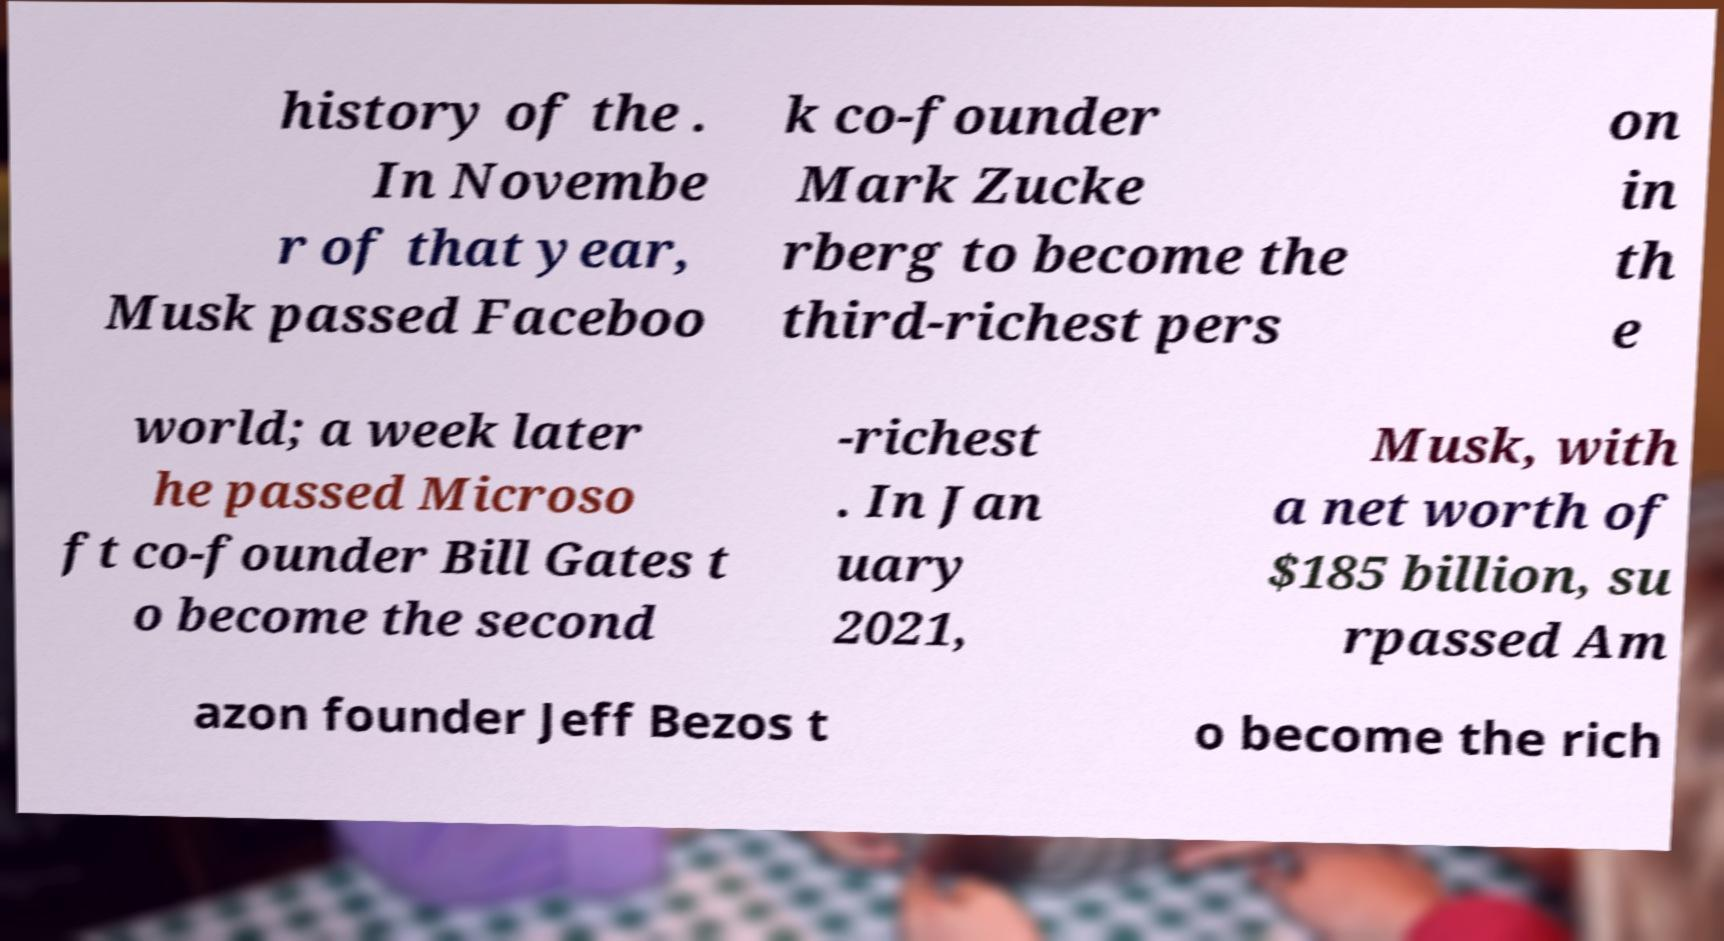What messages or text are displayed in this image? I need them in a readable, typed format. history of the . In Novembe r of that year, Musk passed Faceboo k co-founder Mark Zucke rberg to become the third-richest pers on in th e world; a week later he passed Microso ft co-founder Bill Gates t o become the second -richest . In Jan uary 2021, Musk, with a net worth of $185 billion, su rpassed Am azon founder Jeff Bezos t o become the rich 